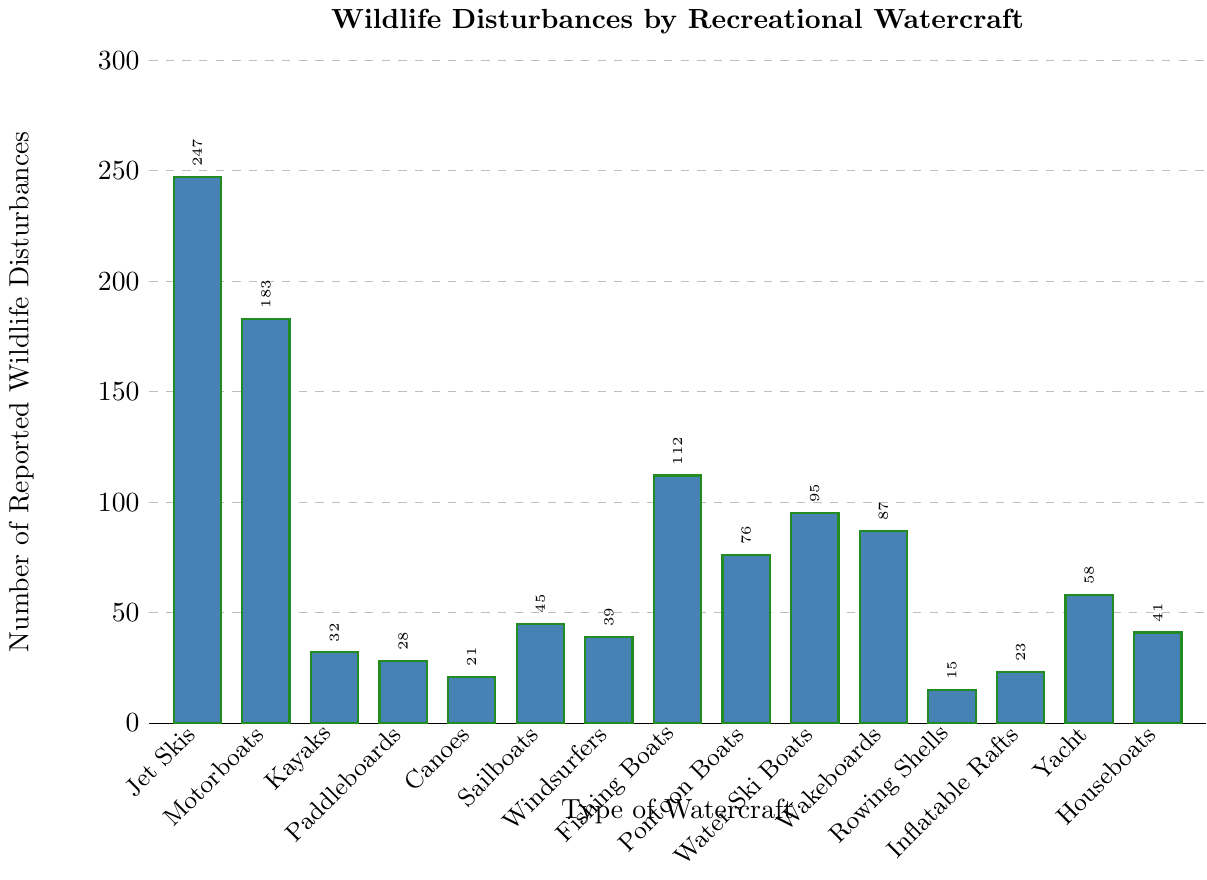What's the type of watercraft with the highest reported wildlife disturbances? By comparing the bars' heights, the Jet Skis bar is the tallest, indicating the highest number of reported wildlife disturbances.
Answer: Jet Skis Which type of watercraft has the fewest reported wildlife disturbances? By comparing the bars' heights, the Rowing Shells bar is the shortest, indicating the fewest number of reported wildlife disturbances.
Answer: Rowing Shells How many more wildlife disturbances are reported for Jet Skis compared to Motorboats? The bar heights show that Jet Skis have 247 reported disturbances and Motorboats have 183. The difference is 247 - 183.
Answer: 64 What is the total number of reported wildlife disturbances for non-motorized watercraft (Kayaks, Paddleboards, Canoes, Windsurfers, Rowing Shells, Inflatable Rafts)? Summing the reported disturbances for each: Kayaks (32) + Paddleboards (28) + Canoes (21) + Windsurfers (39) + Rowing Shells (15) + Inflatable Rafts (23) = 158.
Answer: 158 What's the average number of reported wildlife disturbances for the watercraft types Jet Skis, Motorboats, and Fishing Boats? Sum the disturbances for Jet Skis (247), Motorboats (183), and Fishing Boats (112): 247 + 183 + 112 = 542. Then divide by 3: 542 / 3 = 180.67.
Answer: 180.67 Are there more disturbances reported for Water Ski Boats or Wakeboards? Comparing the bar heights, Water Ski Boats have 95 disturbances, while Wakeboards have 87. Water Ski Boats have more disturbances.
Answer: Water Ski Boats What's the combined total of reported wildlife disturbances for all types of motorized watercraft (Jet Skis, Motorboats, Fishing Boats, Pontoon Boats, Water Ski Boats, Wakeboards, Yacht, Houseboats)? Sum the disturbances: Jet Skis (247) + Motorboats (183) + Fishing Boats (112) + Pontoon Boats (76) + Water Ski Boats (95) + Wakeboards (87) + Yacht (58) + Houseboats (41) = 899.
Answer: 899 Which is the least reported disturbance type among Windsurfers, Kayaks, and Paddleboards? Compare the bars of Windsurfers (39), Kayaks (32), and Paddleboards (28). Paddleboards have the fewest disturbances.
Answer: Paddleboards By how much do the reported disturbances for Houseboats exceed those for Canoes? Houseboats have 41 disturbances, and Canoes have 21 disturbances. The difference is 41 - 21.
Answer: 20 Which type of watercraft has disturbances that are closest to twice the number for Kayaks? Kayaks have 32 disturbances. Twice that is 64. Comparing this number to the bars, Yacht has 58 disturbances, which is the closest to 64.
Answer: Yacht 